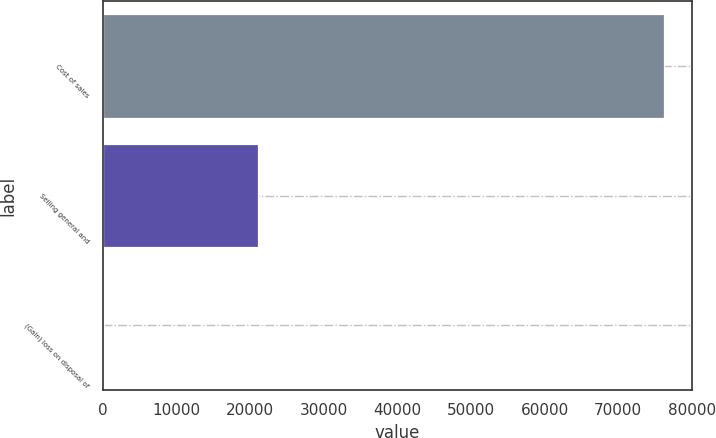Convert chart to OTSL. <chart><loc_0><loc_0><loc_500><loc_500><bar_chart><fcel>Cost of sales<fcel>Selling general and<fcel>(Gain) loss on disposal of<nl><fcel>76197<fcel>21051<fcel>116<nl></chart> 